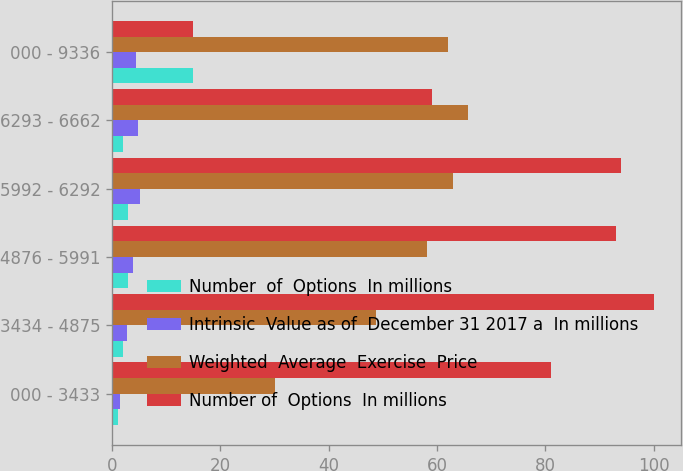Convert chart. <chart><loc_0><loc_0><loc_500><loc_500><stacked_bar_chart><ecel><fcel>000 - 3433<fcel>3434 - 4875<fcel>4876 - 5991<fcel>5992 - 6292<fcel>6293 - 6662<fcel>000 - 9336<nl><fcel>Number  of  Options  In millions<fcel>1<fcel>2<fcel>3<fcel>3<fcel>2<fcel>15<nl><fcel>Intrinsic  Value as of  December 31 2017 a  In millions<fcel>1.4<fcel>2.76<fcel>3.81<fcel>5.21<fcel>4.71<fcel>4.45<nl><fcel>Weighted  Average  Exercise  Price<fcel>30.05<fcel>48.75<fcel>58.19<fcel>62.92<fcel>65.78<fcel>61.97<nl><fcel>Number of  Options  In millions<fcel>81<fcel>100<fcel>93<fcel>94<fcel>59<fcel>15<nl></chart> 